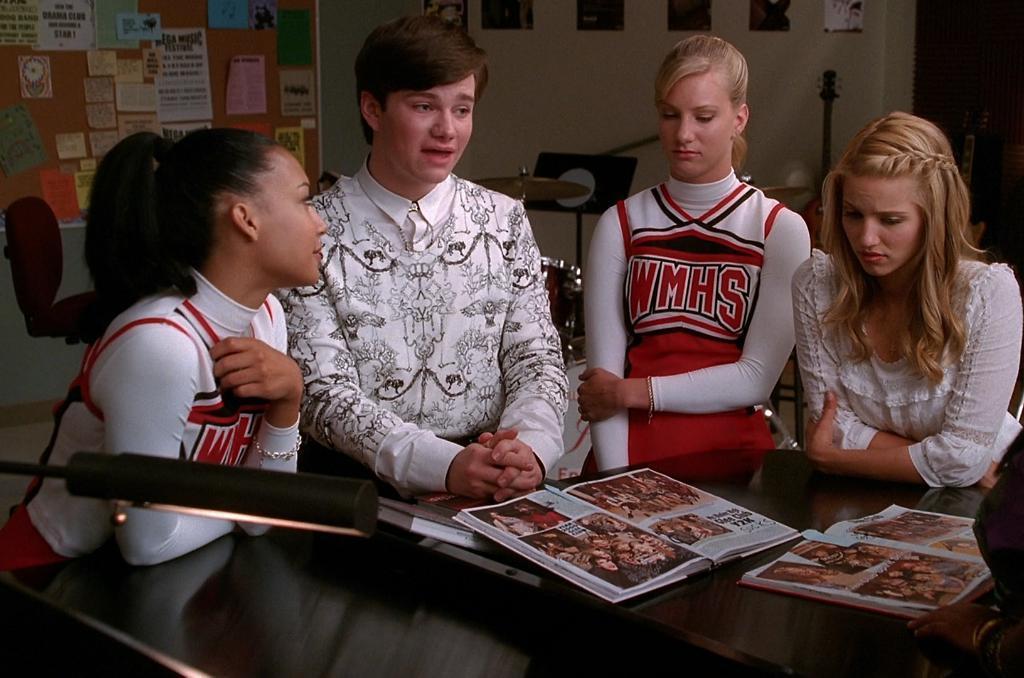Describe this image in one or two sentences. In this picture we can see four people sitting on chairs, table with books on it, light and in the background we can see the wall, posters, musical instruments, chair, some objects. 